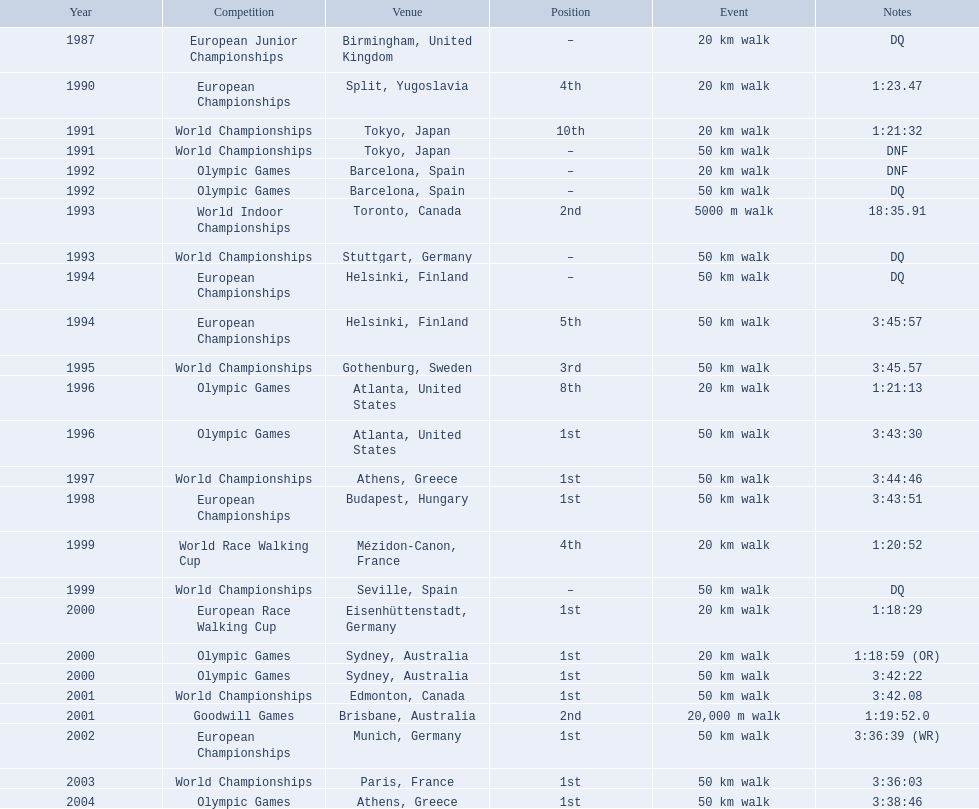What was robert korzeniowski's finishing place in 1990? 4th. What position did robert korzeniowski achieve in the 1993 world indoor championships? 2nd. What was the duration of the 50km walk at the 2004 olympic games? 3:38:46. 